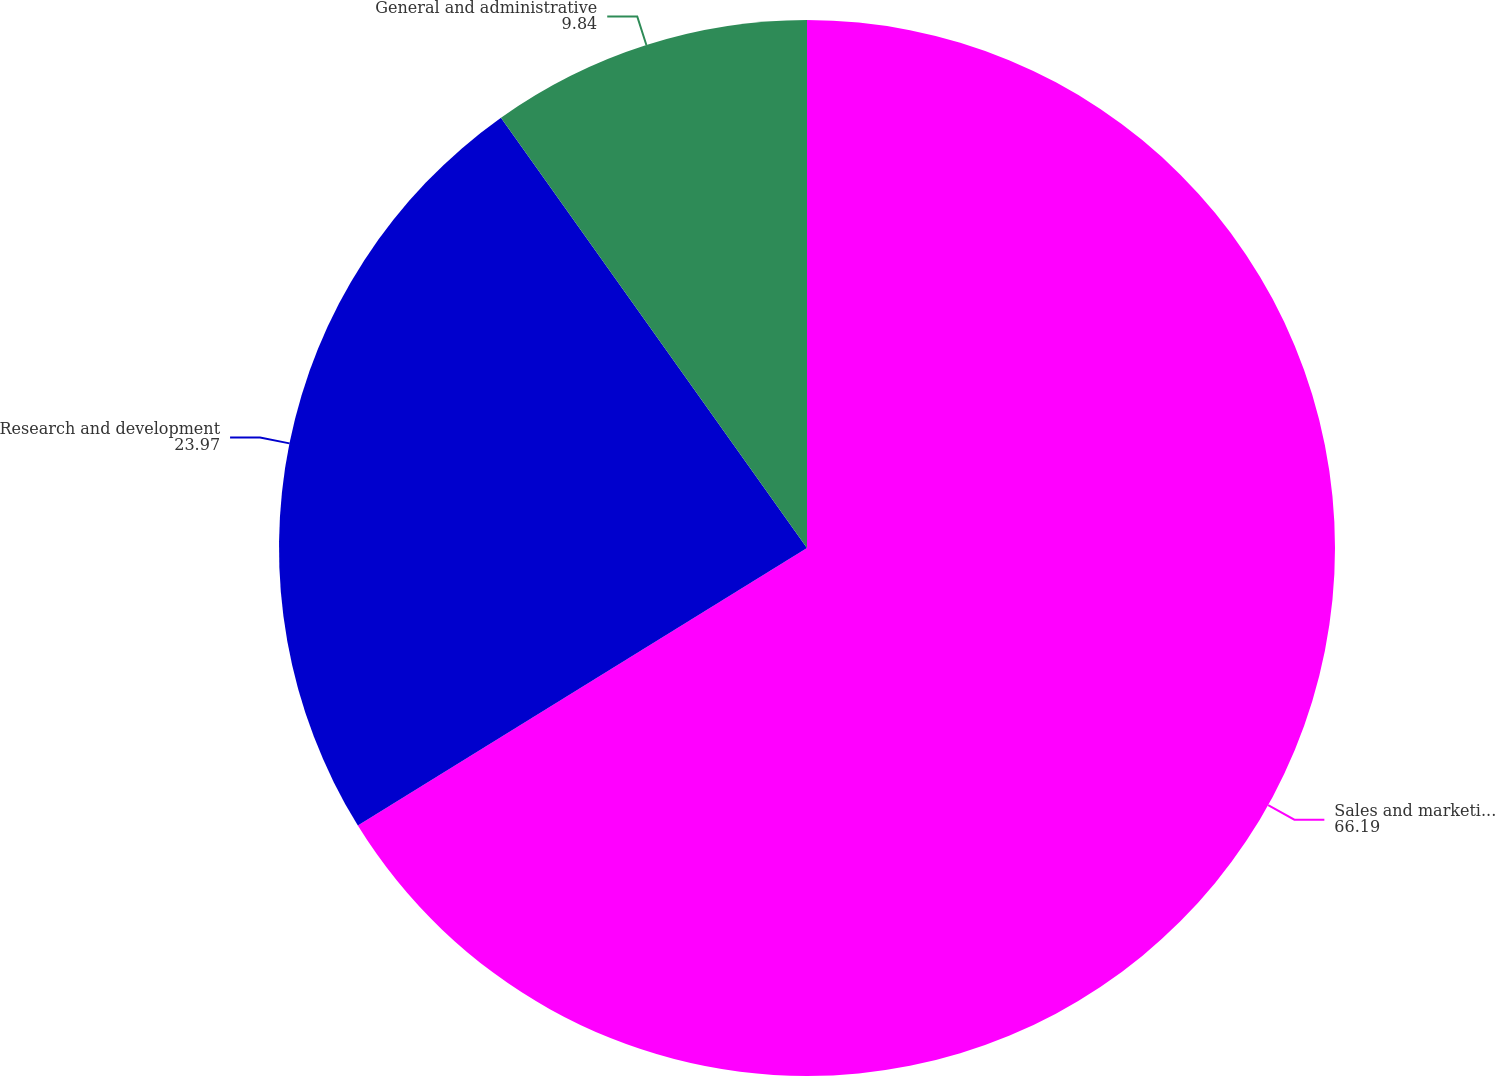Convert chart to OTSL. <chart><loc_0><loc_0><loc_500><loc_500><pie_chart><fcel>Sales and marketing expense<fcel>Research and development<fcel>General and administrative<nl><fcel>66.19%<fcel>23.97%<fcel>9.84%<nl></chart> 